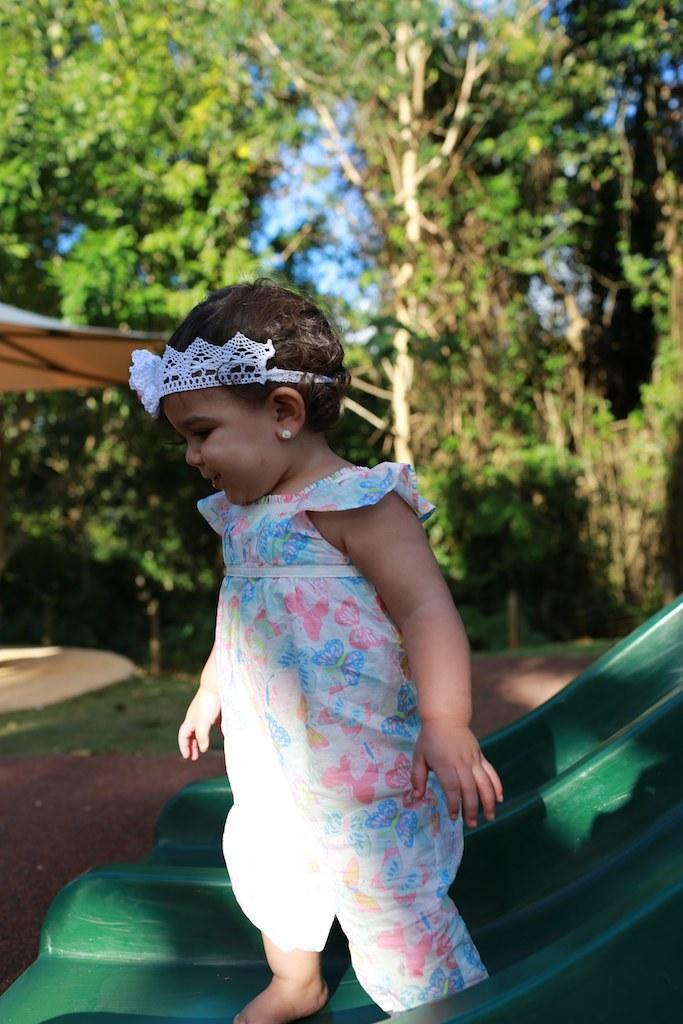Describe this image in one or two sentences. In this image we can see a baby standing on the object which looks like a slide and we can see some trees in the background. 